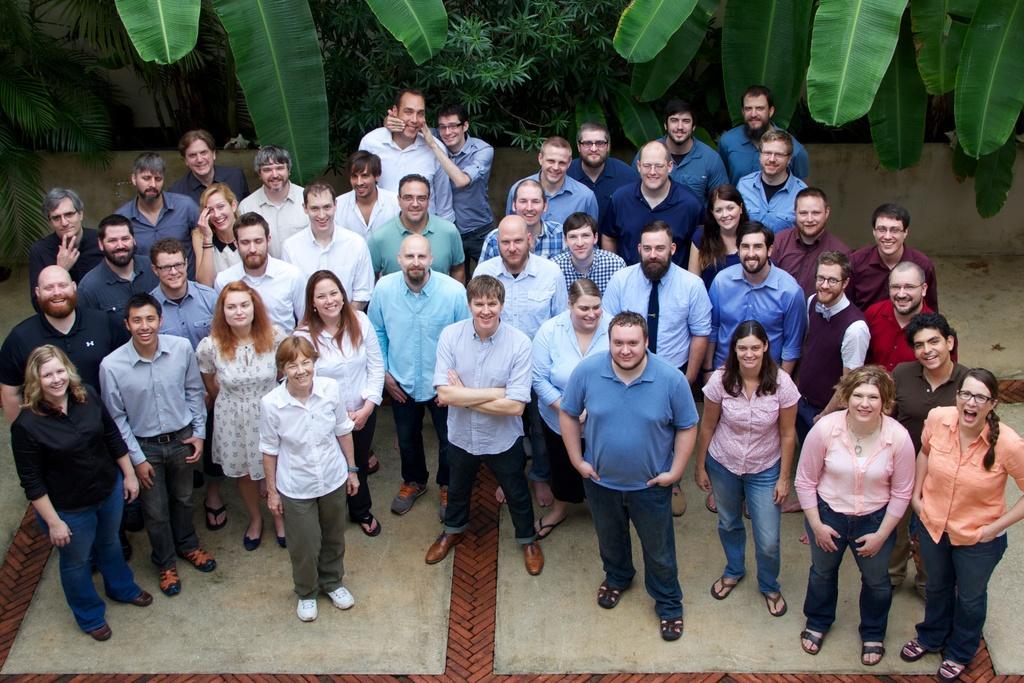Please provide a concise description of this image. In this picture we can see a group of people standing on the ground and smiling and in the background we can see trees, wall. 